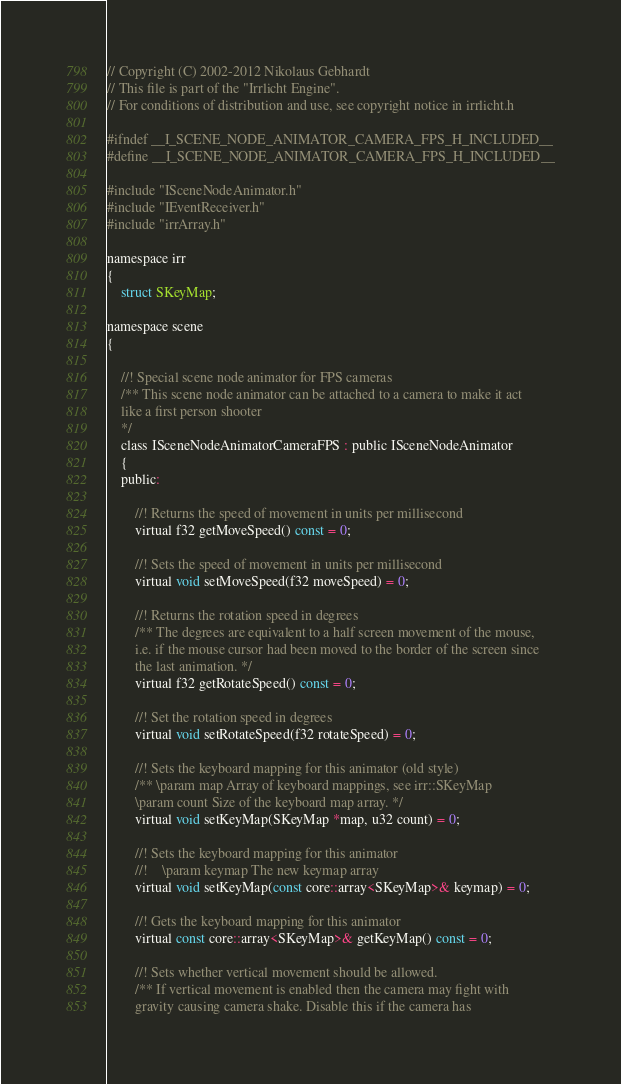<code> <loc_0><loc_0><loc_500><loc_500><_C_>// Copyright (C) 2002-2012 Nikolaus Gebhardt
// This file is part of the "Irrlicht Engine".
// For conditions of distribution and use, see copyright notice in irrlicht.h

#ifndef __I_SCENE_NODE_ANIMATOR_CAMERA_FPS_H_INCLUDED__
#define __I_SCENE_NODE_ANIMATOR_CAMERA_FPS_H_INCLUDED__

#include "ISceneNodeAnimator.h"
#include "IEventReceiver.h"
#include "irrArray.h"

namespace irr
{
    struct SKeyMap;

namespace scene
{

    //! Special scene node animator for FPS cameras
    /** This scene node animator can be attached to a camera to make it act
    like a first person shooter 
    */
    class ISceneNodeAnimatorCameraFPS : public ISceneNodeAnimator
    {
    public:

        //! Returns the speed of movement in units per millisecond
        virtual f32 getMoveSpeed() const = 0;

        //! Sets the speed of movement in units per millisecond
        virtual void setMoveSpeed(f32 moveSpeed) = 0;

        //! Returns the rotation speed in degrees
        /** The degrees are equivalent to a half screen movement of the mouse,
        i.e. if the mouse cursor had been moved to the border of the screen since
        the last animation. */
        virtual f32 getRotateSpeed() const = 0;

        //! Set the rotation speed in degrees
        virtual void setRotateSpeed(f32 rotateSpeed) = 0;

        //! Sets the keyboard mapping for this animator (old style)
        /** \param map Array of keyboard mappings, see irr::SKeyMap
        \param count Size of the keyboard map array. */
        virtual void setKeyMap(SKeyMap *map, u32 count) = 0;

        //! Sets the keyboard mapping for this animator
        //!    \param keymap The new keymap array 
        virtual void setKeyMap(const core::array<SKeyMap>& keymap) = 0;

        //! Gets the keyboard mapping for this animator
        virtual const core::array<SKeyMap>& getKeyMap() const = 0;

        //! Sets whether vertical movement should be allowed.
        /** If vertical movement is enabled then the camera may fight with 
        gravity causing camera shake. Disable this if the camera has </code> 